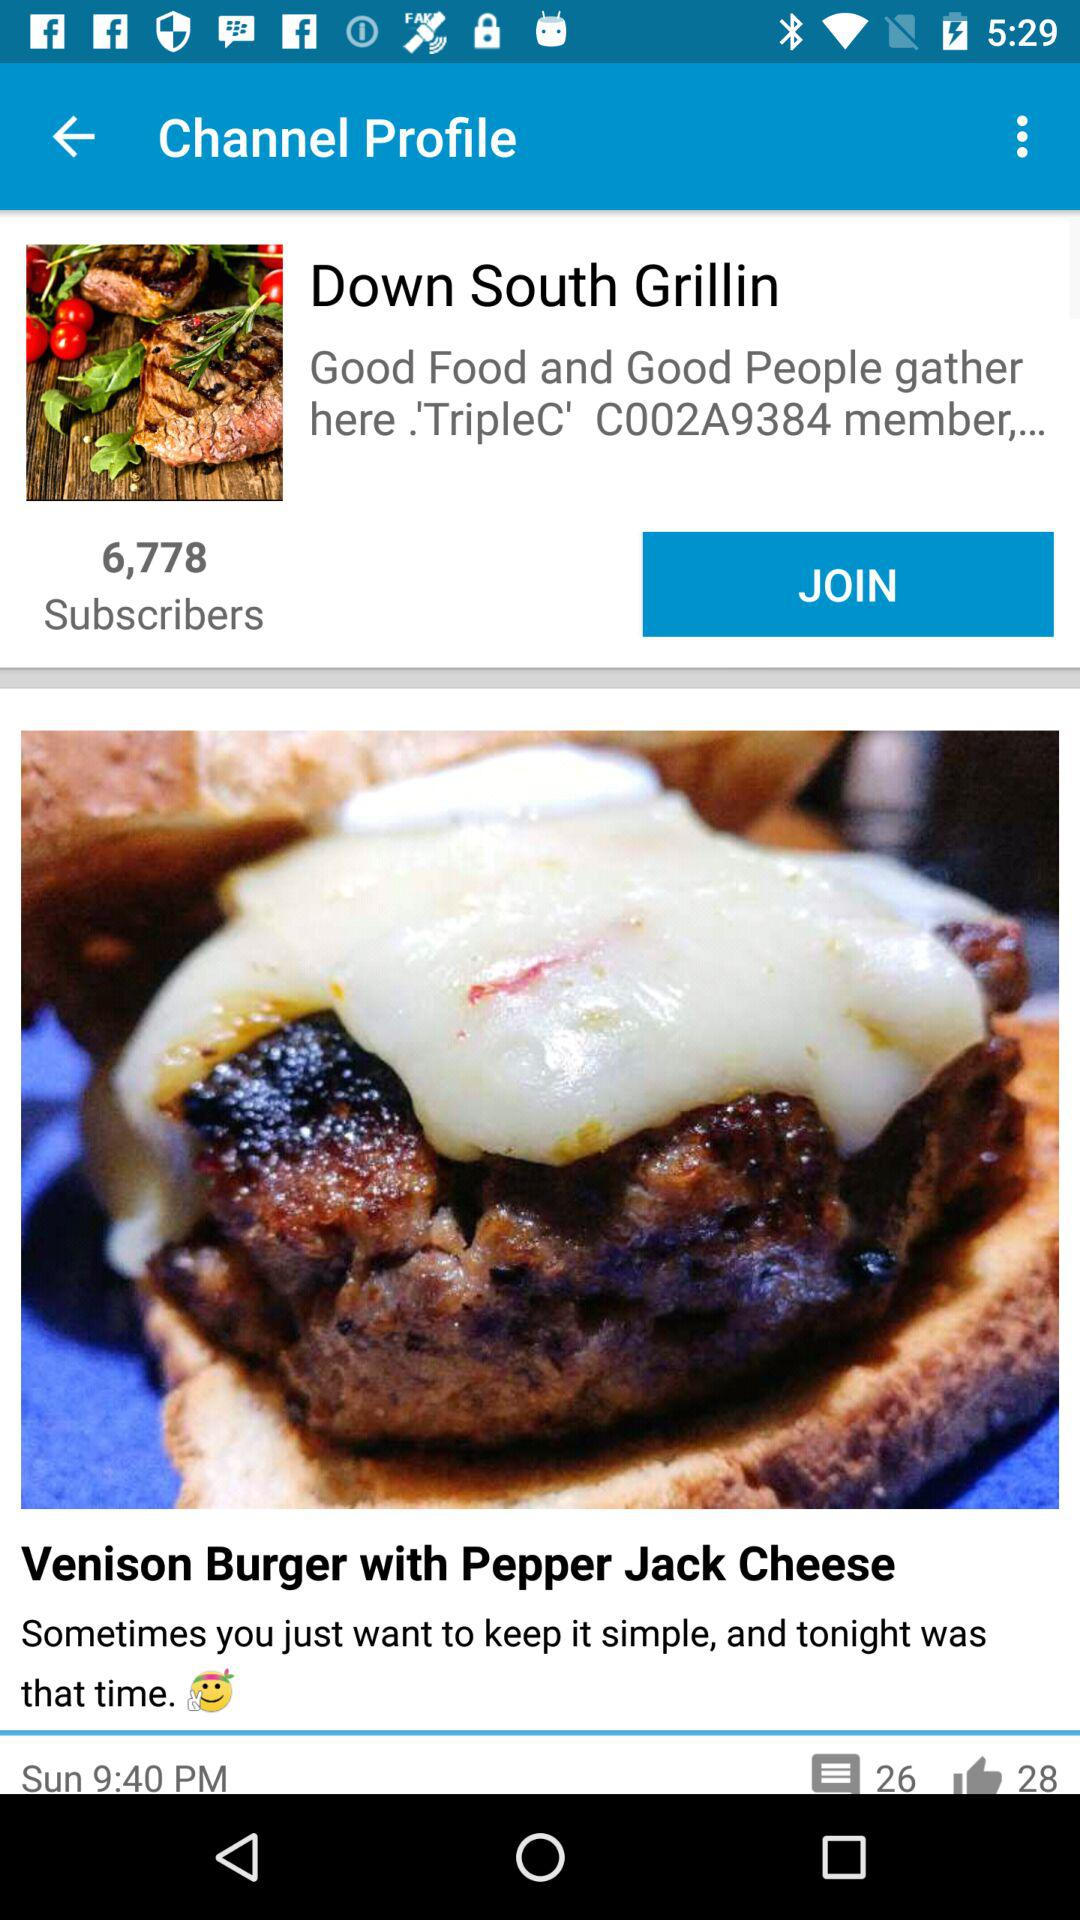What is the given time? The given time is 9:40 PM. 